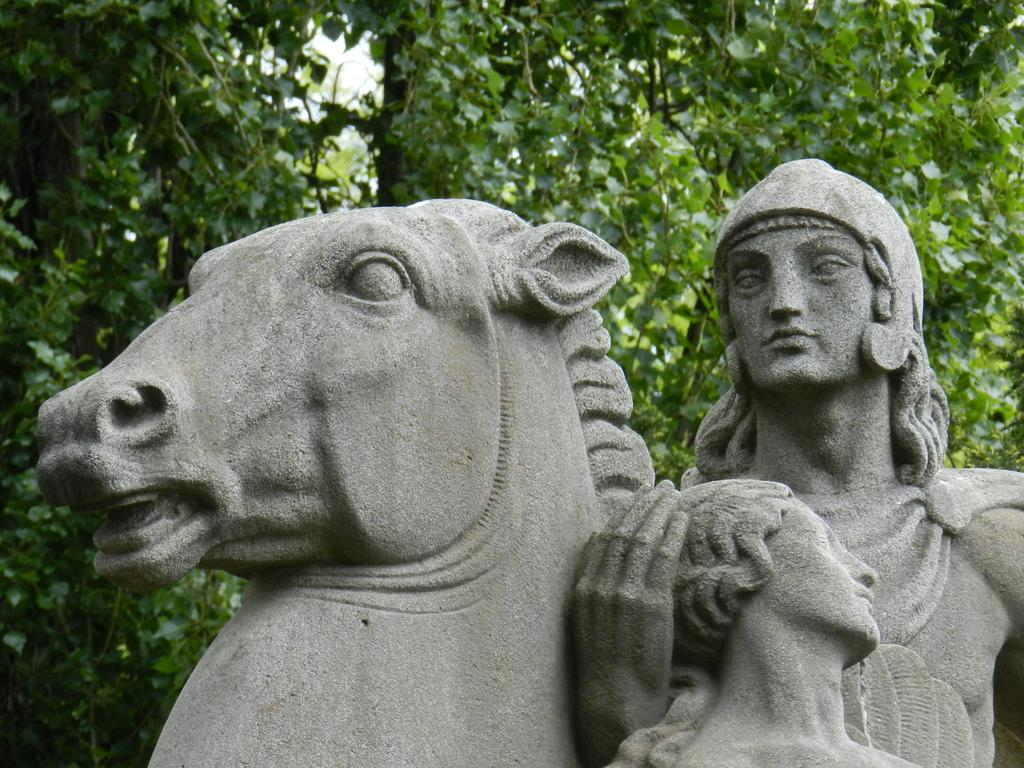What is the main subject in the image? There is a statue in the image. Where is the statue located? The statue is on a platform. What can be seen in the background of the image? There are trees and the sky visible in the background of the image. What type of whip is the father using to control the donkey in the image? There is no whip, father, or donkey present in the image; it only features a statue on a platform with trees and the sky in the background. 